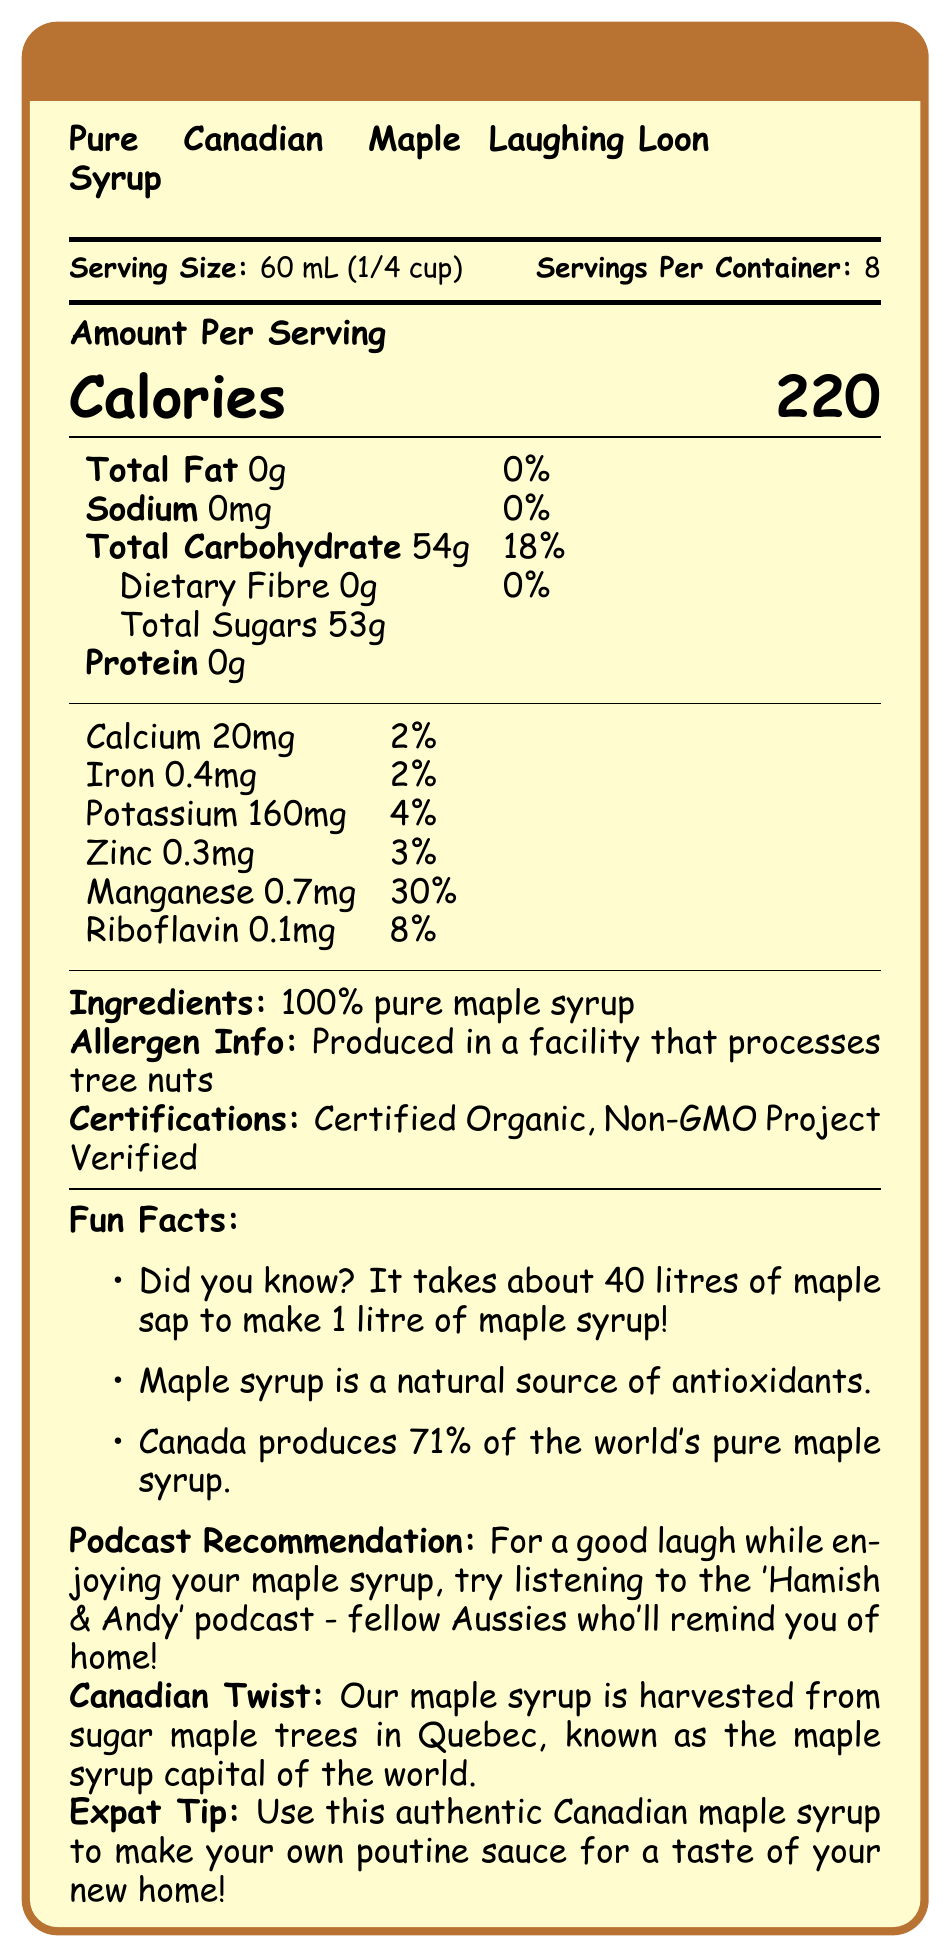what is the serving size of Pure Canadian Maple Syrup? The serving size is explicitly stated as "60 mL (1/4 cup)" in the document.
Answer: 60 mL (1/4 cup) how many calories are there per serving of Laughing Loon maple syrup? The calories per serving are clearly listed as 220 in the document.
Answer: 220 how much total fat does one serving contain? The total fat per serving is indicated as "0g" in the nutritional information.
Answer: 0g why might Laughing Loon maple syrup be recommended for a fan of Aussie comedy podcasts? The document suggests the 'Hamish & Andy' podcast because they are fellow Aussies who can remind you of home.
Answer: For a good laugh, try listening to the 'Hamish & Andy' podcast while enjoying your maple syrup. what percentage of the daily value for carbohydrates does one serving provide? The document states "Total Carbohydrate 54g," which is 18% of the daily value.
Answer: 18% does the maple syrup contain any dietary fiber? The dietary fiber content is shown as 0g, indicating there is no dietary fiber.
Answer: No which of the following contains the main ingredient in Laughing Loon Maple Syrup? A. Corn Syrup B. Honey C. Maple Syrup D. Sugar The ingredients list mentions "100% pure maple syrup" as the only ingredient.
Answer: C. Maple Syrup what is one fun fact listed about maple syrup production? A. It takes about 20 litres of sap to make 1 litre of syrup. B. Maple syrup is a natural source of sugars. C. Canada produces 71% of the world’s pure maple syrup. D. Maple syrup is a natural source of protein. One of the fun facts states "Canada produces 71% of the world's pure maple syrup."
Answer: C. Canada produces 71% of the world’s pure maple syrup. is Laughing Loon Maple Syrup certified organic? The document mentions that the product is "Certified Organic."
Answer: Yes how much calcium is in one serving of the syrup? The calcium content per serving is listed as 20mg in the nutritional information.
Answer: 20mg summarize the main idea of the document. The document offers detailed nutritional information about the maple syrup, highlights its certification and natural content, and shares interesting facts and recommendations for expats and podcast fans.
Answer: The document provides the nutritional facts for Laughing Loon's Pure Canadian Maple Syrup, including serving size, calorie content, and specific nutrient amounts. It emphasizes the natural sugar content and contains fun facts, certification information, and recommendations related to the product. what is the total amount of dietary fiber and protein in one serving? The document lists both dietary fiber and protein as 0g per serving.
Answer: 0g of dietary fiber and 0g of protein can the document provide information on the production methods used for the maple syrup? The document does not detail the production methods; it only lists certifications like "Certified Organic" and "Non-GMO Project Verified."
Answer: Not enough information where is Laughing Loon maple syrup harvested? A. Ontario B. Quebec C. British Columbia D. New Brunswick The document states that the syrup is harvested from sugar maple trees in Quebec, known as the maple syrup capital of the world.
Answer: B. Quebec what is a fun fact about the amount of sap required to make maple syrup? One of the fun facts mentions that it takes about 40 litres of maple sap to produce 1 litre of maple syrup.
Answer: It takes about 40 litres of maple sap to make 1 litre of maple syrup! which micronutrient in Laughing Loon maple syrup has the highest daily value percentage? The content of manganese is 0.7mg, which is 30% of the daily value, the highest percentage among the micronutrients listed.
Answer: Manganese is there any zinc content in one serving of the maple syrup? The document shows that there is 0.3mg of zinc in one serving, which is 3% of the daily value.
Answer: Yes 